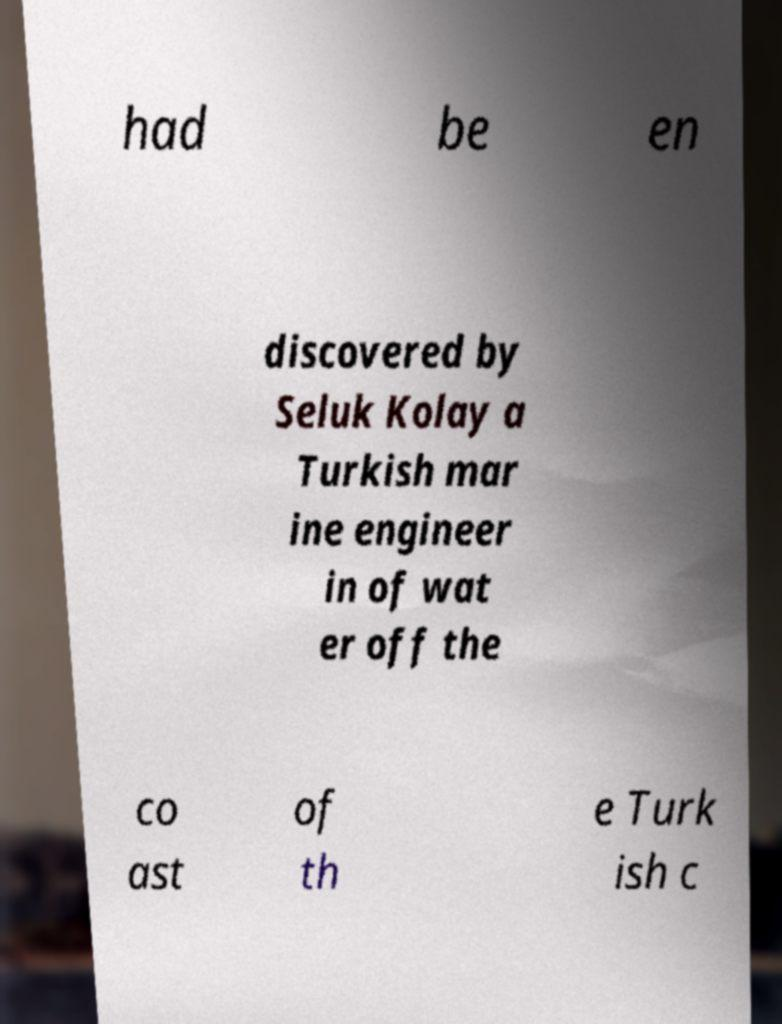Can you read and provide the text displayed in the image?This photo seems to have some interesting text. Can you extract and type it out for me? had be en discovered by Seluk Kolay a Turkish mar ine engineer in of wat er off the co ast of th e Turk ish c 